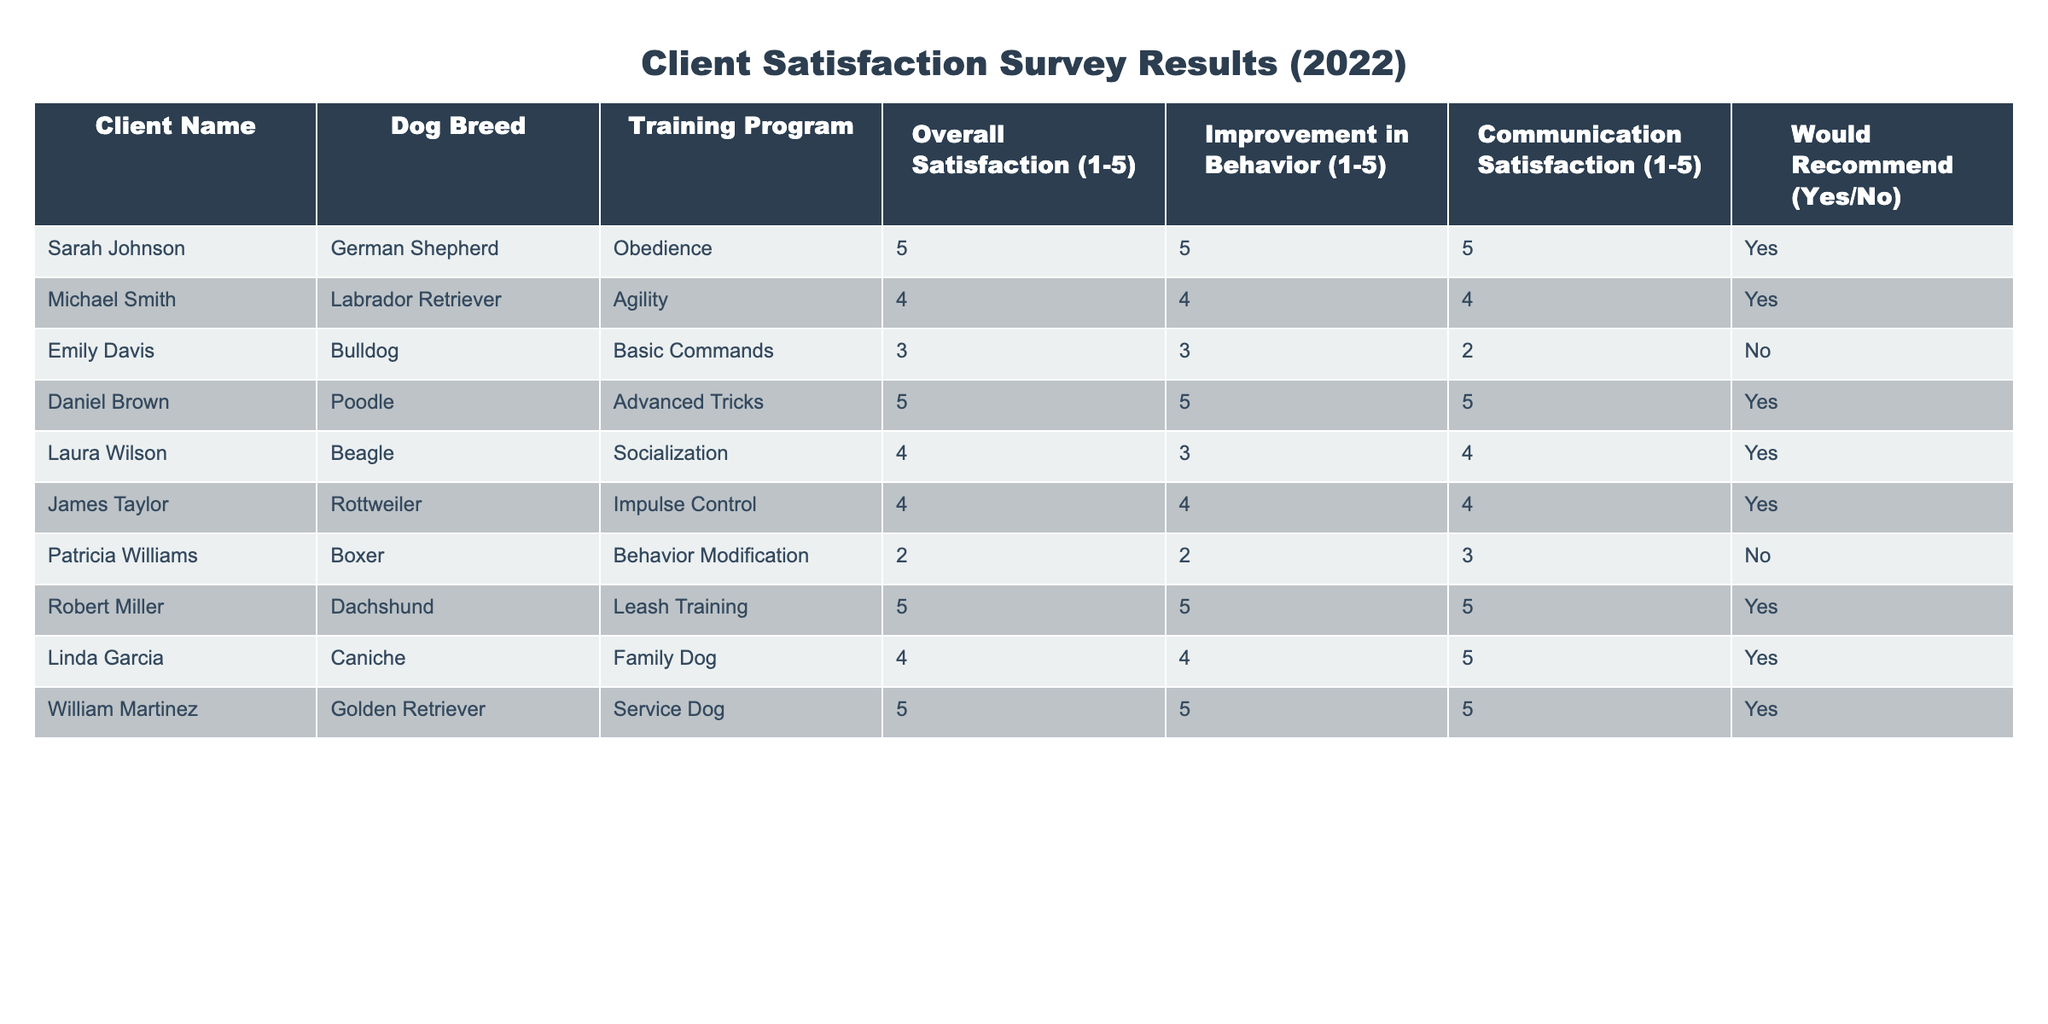What is the overall satisfaction rating of the client with the Poodle? The overall satisfaction rating for the client with the Poodle, Daniel Brown, is located in the “Overall Satisfaction (1-5)” column. Looking at that row, the score is 5.
Answer: 5 How many clients reported an improvement in behavior rating of 5? To find this, we can count the number of rows where the "Improvement in Behavior (1-5)" column equals 5. Upon reviewing the table, there are 3 clients (Daniel Brown, Robert Miller, and William Martinez) who reported this.
Answer: 3 Did any client training a Boxer indicate that they would recommend the service? In the row for Patricia Williams, who owns a Boxer, the "Would Recommend" status is noted as "No". Thus, the client did not recommend the service.
Answer: No What is the average communication satisfaction rating across all clients? To calculate the average communication satisfaction, we sum up all the ratings in the "Communication Satisfaction (1-5)" column: (5 + 4 + 2 + 5 + 4 + 4 + 3 + 5 + 4 + 5) = 47. There are 10 clients in total, so we divide this sum by 10 which results in an average of 4.7.
Answer: 4.7 Which training program had the lowest overall satisfaction rating? By examining the "Overall Satisfaction (1-5)" ratings, the lowest value is 2, which corresponds to the "Behavior Modification" training program. The client associated with this program is Patricia Williams.
Answer: Behavior Modification How many clients are satisfied from the obedience program, judging by their overall satisfaction rating? Clients from the obedience program (Sarah Johnson) reported an overall satisfaction rating of 5, which qualifies as satisfied (ratings of 4 or 5). Thus, there is 1 satisfied client from this program.
Answer: 1 Was there any client who did not improve their dog's behavior but would still recommend the training service? Upon checking the table, Emily Davis with a Bulldog reported an improvement in behavior rating of 3 and would not recommend the service. Thus, there isn’t any client fitting the criteria of not improving but still recommending the service.
Answer: No Which breed had the highest overall satisfaction and what was the score? The highest overall satisfaction rating found in the table is 5, achieved by clients with German Shepherd, Poodle, Dachshund, and Golden Retriever. The breed achieving this score is Poodle owned by Daniel Brown.
Answer: Poodle (5) 